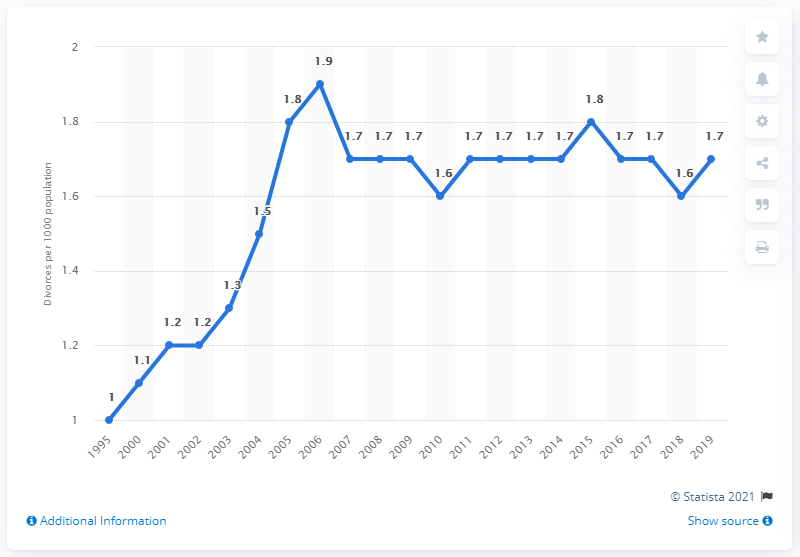Identify some key points in this picture. According to data from 2006, the highest divorce rate in Poland was 1.9 per 1000 people. 